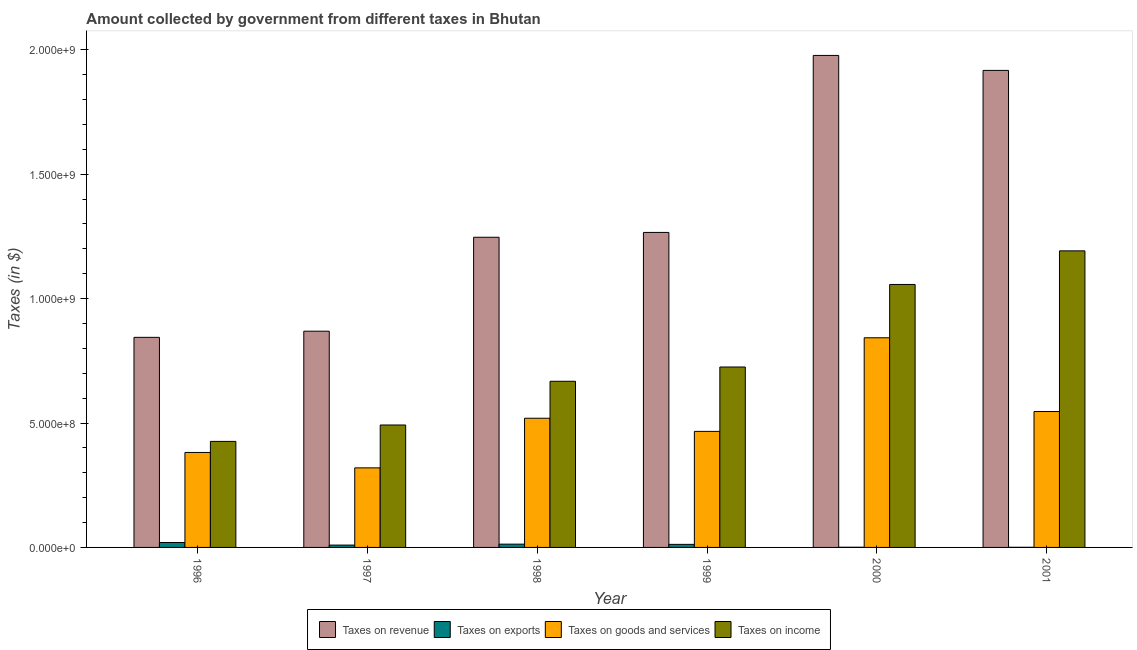How many different coloured bars are there?
Offer a very short reply. 4. How many groups of bars are there?
Your answer should be very brief. 6. Are the number of bars on each tick of the X-axis equal?
Your response must be concise. Yes. What is the amount collected as tax on goods in 1999?
Provide a short and direct response. 4.66e+08. Across all years, what is the maximum amount collected as tax on exports?
Offer a very short reply. 1.98e+07. Across all years, what is the minimum amount collected as tax on exports?
Ensure brevity in your answer.  4.91e+05. In which year was the amount collected as tax on income maximum?
Your answer should be very brief. 2001. In which year was the amount collected as tax on goods minimum?
Offer a very short reply. 1997. What is the total amount collected as tax on goods in the graph?
Provide a succinct answer. 3.08e+09. What is the difference between the amount collected as tax on goods in 1999 and that in 2001?
Your response must be concise. -7.98e+07. What is the difference between the amount collected as tax on revenue in 2001 and the amount collected as tax on goods in 1996?
Offer a very short reply. 1.07e+09. What is the average amount collected as tax on income per year?
Make the answer very short. 7.60e+08. What is the ratio of the amount collected as tax on income in 1996 to that in 1999?
Keep it short and to the point. 0.59. Is the amount collected as tax on goods in 1998 less than that in 1999?
Keep it short and to the point. No. What is the difference between the highest and the second highest amount collected as tax on revenue?
Give a very brief answer. 6.02e+07. What is the difference between the highest and the lowest amount collected as tax on revenue?
Offer a very short reply. 1.13e+09. In how many years, is the amount collected as tax on exports greater than the average amount collected as tax on exports taken over all years?
Keep it short and to the point. 4. Is the sum of the amount collected as tax on income in 1998 and 2001 greater than the maximum amount collected as tax on goods across all years?
Make the answer very short. Yes. Is it the case that in every year, the sum of the amount collected as tax on revenue and amount collected as tax on income is greater than the sum of amount collected as tax on exports and amount collected as tax on goods?
Your answer should be compact. No. What does the 4th bar from the left in 1999 represents?
Give a very brief answer. Taxes on income. What does the 1st bar from the right in 1996 represents?
Give a very brief answer. Taxes on income. Is it the case that in every year, the sum of the amount collected as tax on revenue and amount collected as tax on exports is greater than the amount collected as tax on goods?
Ensure brevity in your answer.  Yes. How many years are there in the graph?
Offer a terse response. 6. What is the difference between two consecutive major ticks on the Y-axis?
Provide a succinct answer. 5.00e+08. Does the graph contain any zero values?
Your answer should be very brief. No. How many legend labels are there?
Provide a short and direct response. 4. How are the legend labels stacked?
Offer a terse response. Horizontal. What is the title of the graph?
Offer a very short reply. Amount collected by government from different taxes in Bhutan. What is the label or title of the X-axis?
Make the answer very short. Year. What is the label or title of the Y-axis?
Give a very brief answer. Taxes (in $). What is the Taxes (in $) in Taxes on revenue in 1996?
Ensure brevity in your answer.  8.44e+08. What is the Taxes (in $) in Taxes on exports in 1996?
Your answer should be very brief. 1.98e+07. What is the Taxes (in $) in Taxes on goods and services in 1996?
Provide a short and direct response. 3.82e+08. What is the Taxes (in $) in Taxes on income in 1996?
Your answer should be very brief. 4.26e+08. What is the Taxes (in $) of Taxes on revenue in 1997?
Offer a terse response. 8.69e+08. What is the Taxes (in $) of Taxes on exports in 1997?
Provide a short and direct response. 9.40e+06. What is the Taxes (in $) in Taxes on goods and services in 1997?
Keep it short and to the point. 3.20e+08. What is the Taxes (in $) of Taxes on income in 1997?
Provide a succinct answer. 4.92e+08. What is the Taxes (in $) in Taxes on revenue in 1998?
Provide a succinct answer. 1.25e+09. What is the Taxes (in $) of Taxes on exports in 1998?
Your answer should be very brief. 1.32e+07. What is the Taxes (in $) in Taxes on goods and services in 1998?
Your answer should be compact. 5.19e+08. What is the Taxes (in $) of Taxes on income in 1998?
Give a very brief answer. 6.68e+08. What is the Taxes (in $) in Taxes on revenue in 1999?
Keep it short and to the point. 1.27e+09. What is the Taxes (in $) in Taxes on exports in 1999?
Give a very brief answer. 1.23e+07. What is the Taxes (in $) in Taxes on goods and services in 1999?
Offer a terse response. 4.66e+08. What is the Taxes (in $) of Taxes on income in 1999?
Your answer should be very brief. 7.25e+08. What is the Taxes (in $) in Taxes on revenue in 2000?
Your response must be concise. 1.98e+09. What is the Taxes (in $) of Taxes on exports in 2000?
Keep it short and to the point. 7.63e+05. What is the Taxes (in $) of Taxes on goods and services in 2000?
Your answer should be compact. 8.42e+08. What is the Taxes (in $) in Taxes on income in 2000?
Provide a short and direct response. 1.06e+09. What is the Taxes (in $) of Taxes on revenue in 2001?
Provide a succinct answer. 1.92e+09. What is the Taxes (in $) in Taxes on exports in 2001?
Offer a very short reply. 4.91e+05. What is the Taxes (in $) of Taxes on goods and services in 2001?
Keep it short and to the point. 5.46e+08. What is the Taxes (in $) in Taxes on income in 2001?
Offer a very short reply. 1.19e+09. Across all years, what is the maximum Taxes (in $) of Taxes on revenue?
Keep it short and to the point. 1.98e+09. Across all years, what is the maximum Taxes (in $) of Taxes on exports?
Make the answer very short. 1.98e+07. Across all years, what is the maximum Taxes (in $) of Taxes on goods and services?
Ensure brevity in your answer.  8.42e+08. Across all years, what is the maximum Taxes (in $) of Taxes on income?
Provide a short and direct response. 1.19e+09. Across all years, what is the minimum Taxes (in $) in Taxes on revenue?
Provide a short and direct response. 8.44e+08. Across all years, what is the minimum Taxes (in $) in Taxes on exports?
Keep it short and to the point. 4.91e+05. Across all years, what is the minimum Taxes (in $) of Taxes on goods and services?
Offer a very short reply. 3.20e+08. Across all years, what is the minimum Taxes (in $) of Taxes on income?
Give a very brief answer. 4.26e+08. What is the total Taxes (in $) of Taxes on revenue in the graph?
Provide a short and direct response. 8.12e+09. What is the total Taxes (in $) in Taxes on exports in the graph?
Provide a succinct answer. 5.59e+07. What is the total Taxes (in $) in Taxes on goods and services in the graph?
Your response must be concise. 3.08e+09. What is the total Taxes (in $) of Taxes on income in the graph?
Provide a short and direct response. 4.56e+09. What is the difference between the Taxes (in $) in Taxes on revenue in 1996 and that in 1997?
Make the answer very short. -2.47e+07. What is the difference between the Taxes (in $) of Taxes on exports in 1996 and that in 1997?
Provide a succinct answer. 1.04e+07. What is the difference between the Taxes (in $) of Taxes on goods and services in 1996 and that in 1997?
Your response must be concise. 6.19e+07. What is the difference between the Taxes (in $) in Taxes on income in 1996 and that in 1997?
Provide a short and direct response. -6.59e+07. What is the difference between the Taxes (in $) in Taxes on revenue in 1996 and that in 1998?
Ensure brevity in your answer.  -4.02e+08. What is the difference between the Taxes (in $) of Taxes on exports in 1996 and that in 1998?
Your answer should be very brief. 6.60e+06. What is the difference between the Taxes (in $) in Taxes on goods and services in 1996 and that in 1998?
Ensure brevity in your answer.  -1.38e+08. What is the difference between the Taxes (in $) in Taxes on income in 1996 and that in 1998?
Offer a very short reply. -2.42e+08. What is the difference between the Taxes (in $) of Taxes on revenue in 1996 and that in 1999?
Give a very brief answer. -4.22e+08. What is the difference between the Taxes (in $) in Taxes on exports in 1996 and that in 1999?
Make the answer very short. 7.51e+06. What is the difference between the Taxes (in $) of Taxes on goods and services in 1996 and that in 1999?
Make the answer very short. -8.47e+07. What is the difference between the Taxes (in $) of Taxes on income in 1996 and that in 1999?
Your response must be concise. -2.99e+08. What is the difference between the Taxes (in $) in Taxes on revenue in 1996 and that in 2000?
Make the answer very short. -1.13e+09. What is the difference between the Taxes (in $) of Taxes on exports in 1996 and that in 2000?
Provide a short and direct response. 1.90e+07. What is the difference between the Taxes (in $) of Taxes on goods and services in 1996 and that in 2000?
Provide a short and direct response. -4.61e+08. What is the difference between the Taxes (in $) of Taxes on income in 1996 and that in 2000?
Provide a succinct answer. -6.31e+08. What is the difference between the Taxes (in $) of Taxes on revenue in 1996 and that in 2001?
Your response must be concise. -1.07e+09. What is the difference between the Taxes (in $) of Taxes on exports in 1996 and that in 2001?
Offer a very short reply. 1.93e+07. What is the difference between the Taxes (in $) of Taxes on goods and services in 1996 and that in 2001?
Ensure brevity in your answer.  -1.64e+08. What is the difference between the Taxes (in $) in Taxes on income in 1996 and that in 2001?
Offer a terse response. -7.66e+08. What is the difference between the Taxes (in $) of Taxes on revenue in 1997 and that in 1998?
Give a very brief answer. -3.77e+08. What is the difference between the Taxes (in $) in Taxes on exports in 1997 and that in 1998?
Your response must be concise. -3.80e+06. What is the difference between the Taxes (in $) of Taxes on goods and services in 1997 and that in 1998?
Your answer should be very brief. -1.99e+08. What is the difference between the Taxes (in $) of Taxes on income in 1997 and that in 1998?
Make the answer very short. -1.76e+08. What is the difference between the Taxes (in $) of Taxes on revenue in 1997 and that in 1999?
Provide a short and direct response. -3.97e+08. What is the difference between the Taxes (in $) of Taxes on exports in 1997 and that in 1999?
Your response must be concise. -2.89e+06. What is the difference between the Taxes (in $) of Taxes on goods and services in 1997 and that in 1999?
Your response must be concise. -1.47e+08. What is the difference between the Taxes (in $) of Taxes on income in 1997 and that in 1999?
Ensure brevity in your answer.  -2.33e+08. What is the difference between the Taxes (in $) in Taxes on revenue in 1997 and that in 2000?
Offer a terse response. -1.11e+09. What is the difference between the Taxes (in $) of Taxes on exports in 1997 and that in 2000?
Ensure brevity in your answer.  8.64e+06. What is the difference between the Taxes (in $) of Taxes on goods and services in 1997 and that in 2000?
Make the answer very short. -5.23e+08. What is the difference between the Taxes (in $) of Taxes on income in 1997 and that in 2000?
Provide a short and direct response. -5.65e+08. What is the difference between the Taxes (in $) in Taxes on revenue in 1997 and that in 2001?
Ensure brevity in your answer.  -1.05e+09. What is the difference between the Taxes (in $) of Taxes on exports in 1997 and that in 2001?
Provide a short and direct response. 8.91e+06. What is the difference between the Taxes (in $) in Taxes on goods and services in 1997 and that in 2001?
Keep it short and to the point. -2.26e+08. What is the difference between the Taxes (in $) in Taxes on income in 1997 and that in 2001?
Provide a short and direct response. -7.00e+08. What is the difference between the Taxes (in $) in Taxes on revenue in 1998 and that in 1999?
Offer a terse response. -1.94e+07. What is the difference between the Taxes (in $) of Taxes on exports in 1998 and that in 1999?
Give a very brief answer. 9.06e+05. What is the difference between the Taxes (in $) in Taxes on goods and services in 1998 and that in 1999?
Provide a succinct answer. 5.28e+07. What is the difference between the Taxes (in $) of Taxes on income in 1998 and that in 1999?
Provide a succinct answer. -5.73e+07. What is the difference between the Taxes (in $) of Taxes on revenue in 1998 and that in 2000?
Your answer should be very brief. -7.31e+08. What is the difference between the Taxes (in $) in Taxes on exports in 1998 and that in 2000?
Make the answer very short. 1.24e+07. What is the difference between the Taxes (in $) of Taxes on goods and services in 1998 and that in 2000?
Make the answer very short. -3.23e+08. What is the difference between the Taxes (in $) of Taxes on income in 1998 and that in 2000?
Make the answer very short. -3.89e+08. What is the difference between the Taxes (in $) in Taxes on revenue in 1998 and that in 2001?
Your response must be concise. -6.71e+08. What is the difference between the Taxes (in $) of Taxes on exports in 1998 and that in 2001?
Make the answer very short. 1.27e+07. What is the difference between the Taxes (in $) of Taxes on goods and services in 1998 and that in 2001?
Offer a very short reply. -2.70e+07. What is the difference between the Taxes (in $) in Taxes on income in 1998 and that in 2001?
Make the answer very short. -5.24e+08. What is the difference between the Taxes (in $) in Taxes on revenue in 1999 and that in 2000?
Give a very brief answer. -7.11e+08. What is the difference between the Taxes (in $) of Taxes on exports in 1999 and that in 2000?
Ensure brevity in your answer.  1.15e+07. What is the difference between the Taxes (in $) of Taxes on goods and services in 1999 and that in 2000?
Keep it short and to the point. -3.76e+08. What is the difference between the Taxes (in $) in Taxes on income in 1999 and that in 2000?
Your response must be concise. -3.32e+08. What is the difference between the Taxes (in $) in Taxes on revenue in 1999 and that in 2001?
Ensure brevity in your answer.  -6.51e+08. What is the difference between the Taxes (in $) of Taxes on exports in 1999 and that in 2001?
Make the answer very short. 1.18e+07. What is the difference between the Taxes (in $) of Taxes on goods and services in 1999 and that in 2001?
Your response must be concise. -7.98e+07. What is the difference between the Taxes (in $) in Taxes on income in 1999 and that in 2001?
Provide a short and direct response. -4.67e+08. What is the difference between the Taxes (in $) of Taxes on revenue in 2000 and that in 2001?
Your answer should be very brief. 6.02e+07. What is the difference between the Taxes (in $) of Taxes on exports in 2000 and that in 2001?
Provide a short and direct response. 2.72e+05. What is the difference between the Taxes (in $) of Taxes on goods and services in 2000 and that in 2001?
Offer a very short reply. 2.96e+08. What is the difference between the Taxes (in $) of Taxes on income in 2000 and that in 2001?
Keep it short and to the point. -1.35e+08. What is the difference between the Taxes (in $) of Taxes on revenue in 1996 and the Taxes (in $) of Taxes on exports in 1997?
Offer a terse response. 8.35e+08. What is the difference between the Taxes (in $) in Taxes on revenue in 1996 and the Taxes (in $) in Taxes on goods and services in 1997?
Provide a succinct answer. 5.24e+08. What is the difference between the Taxes (in $) in Taxes on revenue in 1996 and the Taxes (in $) in Taxes on income in 1997?
Make the answer very short. 3.52e+08. What is the difference between the Taxes (in $) in Taxes on exports in 1996 and the Taxes (in $) in Taxes on goods and services in 1997?
Make the answer very short. -3.00e+08. What is the difference between the Taxes (in $) of Taxes on exports in 1996 and the Taxes (in $) of Taxes on income in 1997?
Your response must be concise. -4.72e+08. What is the difference between the Taxes (in $) of Taxes on goods and services in 1996 and the Taxes (in $) of Taxes on income in 1997?
Keep it short and to the point. -1.10e+08. What is the difference between the Taxes (in $) of Taxes on revenue in 1996 and the Taxes (in $) of Taxes on exports in 1998?
Ensure brevity in your answer.  8.31e+08. What is the difference between the Taxes (in $) of Taxes on revenue in 1996 and the Taxes (in $) of Taxes on goods and services in 1998?
Keep it short and to the point. 3.25e+08. What is the difference between the Taxes (in $) in Taxes on revenue in 1996 and the Taxes (in $) in Taxes on income in 1998?
Offer a very short reply. 1.77e+08. What is the difference between the Taxes (in $) of Taxes on exports in 1996 and the Taxes (in $) of Taxes on goods and services in 1998?
Give a very brief answer. -4.99e+08. What is the difference between the Taxes (in $) in Taxes on exports in 1996 and the Taxes (in $) in Taxes on income in 1998?
Keep it short and to the point. -6.48e+08. What is the difference between the Taxes (in $) in Taxes on goods and services in 1996 and the Taxes (in $) in Taxes on income in 1998?
Make the answer very short. -2.86e+08. What is the difference between the Taxes (in $) of Taxes on revenue in 1996 and the Taxes (in $) of Taxes on exports in 1999?
Ensure brevity in your answer.  8.32e+08. What is the difference between the Taxes (in $) of Taxes on revenue in 1996 and the Taxes (in $) of Taxes on goods and services in 1999?
Ensure brevity in your answer.  3.78e+08. What is the difference between the Taxes (in $) in Taxes on revenue in 1996 and the Taxes (in $) in Taxes on income in 1999?
Make the answer very short. 1.19e+08. What is the difference between the Taxes (in $) of Taxes on exports in 1996 and the Taxes (in $) of Taxes on goods and services in 1999?
Your answer should be very brief. -4.46e+08. What is the difference between the Taxes (in $) of Taxes on exports in 1996 and the Taxes (in $) of Taxes on income in 1999?
Provide a succinct answer. -7.05e+08. What is the difference between the Taxes (in $) in Taxes on goods and services in 1996 and the Taxes (in $) in Taxes on income in 1999?
Your answer should be compact. -3.43e+08. What is the difference between the Taxes (in $) in Taxes on revenue in 1996 and the Taxes (in $) in Taxes on exports in 2000?
Your response must be concise. 8.43e+08. What is the difference between the Taxes (in $) of Taxes on revenue in 1996 and the Taxes (in $) of Taxes on goods and services in 2000?
Provide a short and direct response. 1.70e+06. What is the difference between the Taxes (in $) of Taxes on revenue in 1996 and the Taxes (in $) of Taxes on income in 2000?
Provide a succinct answer. -2.12e+08. What is the difference between the Taxes (in $) of Taxes on exports in 1996 and the Taxes (in $) of Taxes on goods and services in 2000?
Give a very brief answer. -8.23e+08. What is the difference between the Taxes (in $) of Taxes on exports in 1996 and the Taxes (in $) of Taxes on income in 2000?
Make the answer very short. -1.04e+09. What is the difference between the Taxes (in $) in Taxes on goods and services in 1996 and the Taxes (in $) in Taxes on income in 2000?
Give a very brief answer. -6.75e+08. What is the difference between the Taxes (in $) of Taxes on revenue in 1996 and the Taxes (in $) of Taxes on exports in 2001?
Keep it short and to the point. 8.44e+08. What is the difference between the Taxes (in $) of Taxes on revenue in 1996 and the Taxes (in $) of Taxes on goods and services in 2001?
Provide a short and direct response. 2.98e+08. What is the difference between the Taxes (in $) of Taxes on revenue in 1996 and the Taxes (in $) of Taxes on income in 2001?
Provide a short and direct response. -3.48e+08. What is the difference between the Taxes (in $) of Taxes on exports in 1996 and the Taxes (in $) of Taxes on goods and services in 2001?
Your answer should be compact. -5.26e+08. What is the difference between the Taxes (in $) in Taxes on exports in 1996 and the Taxes (in $) in Taxes on income in 2001?
Provide a short and direct response. -1.17e+09. What is the difference between the Taxes (in $) of Taxes on goods and services in 1996 and the Taxes (in $) of Taxes on income in 2001?
Your answer should be compact. -8.10e+08. What is the difference between the Taxes (in $) of Taxes on revenue in 1997 and the Taxes (in $) of Taxes on exports in 1998?
Your answer should be very brief. 8.56e+08. What is the difference between the Taxes (in $) in Taxes on revenue in 1997 and the Taxes (in $) in Taxes on goods and services in 1998?
Offer a very short reply. 3.50e+08. What is the difference between the Taxes (in $) in Taxes on revenue in 1997 and the Taxes (in $) in Taxes on income in 1998?
Give a very brief answer. 2.01e+08. What is the difference between the Taxes (in $) in Taxes on exports in 1997 and the Taxes (in $) in Taxes on goods and services in 1998?
Offer a very short reply. -5.10e+08. What is the difference between the Taxes (in $) in Taxes on exports in 1997 and the Taxes (in $) in Taxes on income in 1998?
Give a very brief answer. -6.58e+08. What is the difference between the Taxes (in $) of Taxes on goods and services in 1997 and the Taxes (in $) of Taxes on income in 1998?
Your answer should be very brief. -3.48e+08. What is the difference between the Taxes (in $) in Taxes on revenue in 1997 and the Taxes (in $) in Taxes on exports in 1999?
Keep it short and to the point. 8.57e+08. What is the difference between the Taxes (in $) of Taxes on revenue in 1997 and the Taxes (in $) of Taxes on goods and services in 1999?
Your response must be concise. 4.03e+08. What is the difference between the Taxes (in $) in Taxes on revenue in 1997 and the Taxes (in $) in Taxes on income in 1999?
Give a very brief answer. 1.44e+08. What is the difference between the Taxes (in $) in Taxes on exports in 1997 and the Taxes (in $) in Taxes on goods and services in 1999?
Offer a very short reply. -4.57e+08. What is the difference between the Taxes (in $) of Taxes on exports in 1997 and the Taxes (in $) of Taxes on income in 1999?
Offer a terse response. -7.16e+08. What is the difference between the Taxes (in $) in Taxes on goods and services in 1997 and the Taxes (in $) in Taxes on income in 1999?
Offer a terse response. -4.05e+08. What is the difference between the Taxes (in $) in Taxes on revenue in 1997 and the Taxes (in $) in Taxes on exports in 2000?
Your answer should be compact. 8.68e+08. What is the difference between the Taxes (in $) of Taxes on revenue in 1997 and the Taxes (in $) of Taxes on goods and services in 2000?
Your answer should be very brief. 2.64e+07. What is the difference between the Taxes (in $) in Taxes on revenue in 1997 and the Taxes (in $) in Taxes on income in 2000?
Your answer should be compact. -1.88e+08. What is the difference between the Taxes (in $) of Taxes on exports in 1997 and the Taxes (in $) of Taxes on goods and services in 2000?
Your answer should be very brief. -8.33e+08. What is the difference between the Taxes (in $) of Taxes on exports in 1997 and the Taxes (in $) of Taxes on income in 2000?
Give a very brief answer. -1.05e+09. What is the difference between the Taxes (in $) of Taxes on goods and services in 1997 and the Taxes (in $) of Taxes on income in 2000?
Provide a succinct answer. -7.37e+08. What is the difference between the Taxes (in $) in Taxes on revenue in 1997 and the Taxes (in $) in Taxes on exports in 2001?
Keep it short and to the point. 8.68e+08. What is the difference between the Taxes (in $) of Taxes on revenue in 1997 and the Taxes (in $) of Taxes on goods and services in 2001?
Give a very brief answer. 3.23e+08. What is the difference between the Taxes (in $) in Taxes on revenue in 1997 and the Taxes (in $) in Taxes on income in 2001?
Keep it short and to the point. -3.23e+08. What is the difference between the Taxes (in $) in Taxes on exports in 1997 and the Taxes (in $) in Taxes on goods and services in 2001?
Your response must be concise. -5.37e+08. What is the difference between the Taxes (in $) of Taxes on exports in 1997 and the Taxes (in $) of Taxes on income in 2001?
Offer a very short reply. -1.18e+09. What is the difference between the Taxes (in $) of Taxes on goods and services in 1997 and the Taxes (in $) of Taxes on income in 2001?
Ensure brevity in your answer.  -8.72e+08. What is the difference between the Taxes (in $) of Taxes on revenue in 1998 and the Taxes (in $) of Taxes on exports in 1999?
Keep it short and to the point. 1.23e+09. What is the difference between the Taxes (in $) in Taxes on revenue in 1998 and the Taxes (in $) in Taxes on goods and services in 1999?
Provide a short and direct response. 7.80e+08. What is the difference between the Taxes (in $) in Taxes on revenue in 1998 and the Taxes (in $) in Taxes on income in 1999?
Provide a succinct answer. 5.21e+08. What is the difference between the Taxes (in $) of Taxes on exports in 1998 and the Taxes (in $) of Taxes on goods and services in 1999?
Keep it short and to the point. -4.53e+08. What is the difference between the Taxes (in $) of Taxes on exports in 1998 and the Taxes (in $) of Taxes on income in 1999?
Offer a terse response. -7.12e+08. What is the difference between the Taxes (in $) of Taxes on goods and services in 1998 and the Taxes (in $) of Taxes on income in 1999?
Ensure brevity in your answer.  -2.06e+08. What is the difference between the Taxes (in $) of Taxes on revenue in 1998 and the Taxes (in $) of Taxes on exports in 2000?
Give a very brief answer. 1.25e+09. What is the difference between the Taxes (in $) in Taxes on revenue in 1998 and the Taxes (in $) in Taxes on goods and services in 2000?
Your answer should be very brief. 4.04e+08. What is the difference between the Taxes (in $) of Taxes on revenue in 1998 and the Taxes (in $) of Taxes on income in 2000?
Your response must be concise. 1.90e+08. What is the difference between the Taxes (in $) of Taxes on exports in 1998 and the Taxes (in $) of Taxes on goods and services in 2000?
Make the answer very short. -8.29e+08. What is the difference between the Taxes (in $) in Taxes on exports in 1998 and the Taxes (in $) in Taxes on income in 2000?
Your response must be concise. -1.04e+09. What is the difference between the Taxes (in $) in Taxes on goods and services in 1998 and the Taxes (in $) in Taxes on income in 2000?
Your response must be concise. -5.38e+08. What is the difference between the Taxes (in $) of Taxes on revenue in 1998 and the Taxes (in $) of Taxes on exports in 2001?
Give a very brief answer. 1.25e+09. What is the difference between the Taxes (in $) in Taxes on revenue in 1998 and the Taxes (in $) in Taxes on goods and services in 2001?
Ensure brevity in your answer.  7.00e+08. What is the difference between the Taxes (in $) of Taxes on revenue in 1998 and the Taxes (in $) of Taxes on income in 2001?
Ensure brevity in your answer.  5.46e+07. What is the difference between the Taxes (in $) of Taxes on exports in 1998 and the Taxes (in $) of Taxes on goods and services in 2001?
Keep it short and to the point. -5.33e+08. What is the difference between the Taxes (in $) in Taxes on exports in 1998 and the Taxes (in $) in Taxes on income in 2001?
Provide a short and direct response. -1.18e+09. What is the difference between the Taxes (in $) in Taxes on goods and services in 1998 and the Taxes (in $) in Taxes on income in 2001?
Provide a short and direct response. -6.73e+08. What is the difference between the Taxes (in $) in Taxes on revenue in 1999 and the Taxes (in $) in Taxes on exports in 2000?
Offer a very short reply. 1.27e+09. What is the difference between the Taxes (in $) in Taxes on revenue in 1999 and the Taxes (in $) in Taxes on goods and services in 2000?
Make the answer very short. 4.23e+08. What is the difference between the Taxes (in $) of Taxes on revenue in 1999 and the Taxes (in $) of Taxes on income in 2000?
Make the answer very short. 2.09e+08. What is the difference between the Taxes (in $) in Taxes on exports in 1999 and the Taxes (in $) in Taxes on goods and services in 2000?
Make the answer very short. -8.30e+08. What is the difference between the Taxes (in $) in Taxes on exports in 1999 and the Taxes (in $) in Taxes on income in 2000?
Provide a succinct answer. -1.04e+09. What is the difference between the Taxes (in $) in Taxes on goods and services in 1999 and the Taxes (in $) in Taxes on income in 2000?
Offer a terse response. -5.90e+08. What is the difference between the Taxes (in $) of Taxes on revenue in 1999 and the Taxes (in $) of Taxes on exports in 2001?
Your answer should be very brief. 1.27e+09. What is the difference between the Taxes (in $) of Taxes on revenue in 1999 and the Taxes (in $) of Taxes on goods and services in 2001?
Offer a terse response. 7.20e+08. What is the difference between the Taxes (in $) of Taxes on revenue in 1999 and the Taxes (in $) of Taxes on income in 2001?
Your answer should be very brief. 7.40e+07. What is the difference between the Taxes (in $) of Taxes on exports in 1999 and the Taxes (in $) of Taxes on goods and services in 2001?
Keep it short and to the point. -5.34e+08. What is the difference between the Taxes (in $) in Taxes on exports in 1999 and the Taxes (in $) in Taxes on income in 2001?
Your response must be concise. -1.18e+09. What is the difference between the Taxes (in $) in Taxes on goods and services in 1999 and the Taxes (in $) in Taxes on income in 2001?
Keep it short and to the point. -7.25e+08. What is the difference between the Taxes (in $) of Taxes on revenue in 2000 and the Taxes (in $) of Taxes on exports in 2001?
Offer a terse response. 1.98e+09. What is the difference between the Taxes (in $) of Taxes on revenue in 2000 and the Taxes (in $) of Taxes on goods and services in 2001?
Your response must be concise. 1.43e+09. What is the difference between the Taxes (in $) in Taxes on revenue in 2000 and the Taxes (in $) in Taxes on income in 2001?
Give a very brief answer. 7.85e+08. What is the difference between the Taxes (in $) of Taxes on exports in 2000 and the Taxes (in $) of Taxes on goods and services in 2001?
Offer a terse response. -5.45e+08. What is the difference between the Taxes (in $) of Taxes on exports in 2000 and the Taxes (in $) of Taxes on income in 2001?
Offer a terse response. -1.19e+09. What is the difference between the Taxes (in $) in Taxes on goods and services in 2000 and the Taxes (in $) in Taxes on income in 2001?
Provide a succinct answer. -3.49e+08. What is the average Taxes (in $) in Taxes on revenue per year?
Provide a succinct answer. 1.35e+09. What is the average Taxes (in $) of Taxes on exports per year?
Provide a succinct answer. 9.32e+06. What is the average Taxes (in $) in Taxes on goods and services per year?
Your answer should be very brief. 5.13e+08. What is the average Taxes (in $) of Taxes on income per year?
Offer a very short reply. 7.60e+08. In the year 1996, what is the difference between the Taxes (in $) of Taxes on revenue and Taxes (in $) of Taxes on exports?
Your response must be concise. 8.24e+08. In the year 1996, what is the difference between the Taxes (in $) of Taxes on revenue and Taxes (in $) of Taxes on goods and services?
Keep it short and to the point. 4.63e+08. In the year 1996, what is the difference between the Taxes (in $) in Taxes on revenue and Taxes (in $) in Taxes on income?
Your answer should be very brief. 4.18e+08. In the year 1996, what is the difference between the Taxes (in $) of Taxes on exports and Taxes (in $) of Taxes on goods and services?
Keep it short and to the point. -3.62e+08. In the year 1996, what is the difference between the Taxes (in $) in Taxes on exports and Taxes (in $) in Taxes on income?
Offer a terse response. -4.06e+08. In the year 1996, what is the difference between the Taxes (in $) of Taxes on goods and services and Taxes (in $) of Taxes on income?
Offer a terse response. -4.45e+07. In the year 1997, what is the difference between the Taxes (in $) in Taxes on revenue and Taxes (in $) in Taxes on exports?
Offer a terse response. 8.60e+08. In the year 1997, what is the difference between the Taxes (in $) of Taxes on revenue and Taxes (in $) of Taxes on goods and services?
Your answer should be compact. 5.49e+08. In the year 1997, what is the difference between the Taxes (in $) of Taxes on revenue and Taxes (in $) of Taxes on income?
Offer a terse response. 3.77e+08. In the year 1997, what is the difference between the Taxes (in $) of Taxes on exports and Taxes (in $) of Taxes on goods and services?
Your answer should be very brief. -3.10e+08. In the year 1997, what is the difference between the Taxes (in $) in Taxes on exports and Taxes (in $) in Taxes on income?
Keep it short and to the point. -4.83e+08. In the year 1997, what is the difference between the Taxes (in $) of Taxes on goods and services and Taxes (in $) of Taxes on income?
Provide a succinct answer. -1.72e+08. In the year 1998, what is the difference between the Taxes (in $) of Taxes on revenue and Taxes (in $) of Taxes on exports?
Provide a short and direct response. 1.23e+09. In the year 1998, what is the difference between the Taxes (in $) in Taxes on revenue and Taxes (in $) in Taxes on goods and services?
Offer a terse response. 7.27e+08. In the year 1998, what is the difference between the Taxes (in $) of Taxes on revenue and Taxes (in $) of Taxes on income?
Make the answer very short. 5.79e+08. In the year 1998, what is the difference between the Taxes (in $) in Taxes on exports and Taxes (in $) in Taxes on goods and services?
Offer a very short reply. -5.06e+08. In the year 1998, what is the difference between the Taxes (in $) in Taxes on exports and Taxes (in $) in Taxes on income?
Provide a short and direct response. -6.54e+08. In the year 1998, what is the difference between the Taxes (in $) in Taxes on goods and services and Taxes (in $) in Taxes on income?
Offer a terse response. -1.49e+08. In the year 1999, what is the difference between the Taxes (in $) of Taxes on revenue and Taxes (in $) of Taxes on exports?
Your answer should be compact. 1.25e+09. In the year 1999, what is the difference between the Taxes (in $) of Taxes on revenue and Taxes (in $) of Taxes on goods and services?
Provide a succinct answer. 8.00e+08. In the year 1999, what is the difference between the Taxes (in $) in Taxes on revenue and Taxes (in $) in Taxes on income?
Provide a short and direct response. 5.41e+08. In the year 1999, what is the difference between the Taxes (in $) in Taxes on exports and Taxes (in $) in Taxes on goods and services?
Give a very brief answer. -4.54e+08. In the year 1999, what is the difference between the Taxes (in $) in Taxes on exports and Taxes (in $) in Taxes on income?
Your answer should be compact. -7.13e+08. In the year 1999, what is the difference between the Taxes (in $) of Taxes on goods and services and Taxes (in $) of Taxes on income?
Your answer should be very brief. -2.59e+08. In the year 2000, what is the difference between the Taxes (in $) in Taxes on revenue and Taxes (in $) in Taxes on exports?
Your answer should be compact. 1.98e+09. In the year 2000, what is the difference between the Taxes (in $) of Taxes on revenue and Taxes (in $) of Taxes on goods and services?
Your answer should be very brief. 1.13e+09. In the year 2000, what is the difference between the Taxes (in $) in Taxes on revenue and Taxes (in $) in Taxes on income?
Give a very brief answer. 9.20e+08. In the year 2000, what is the difference between the Taxes (in $) of Taxes on exports and Taxes (in $) of Taxes on goods and services?
Provide a short and direct response. -8.42e+08. In the year 2000, what is the difference between the Taxes (in $) of Taxes on exports and Taxes (in $) of Taxes on income?
Your answer should be very brief. -1.06e+09. In the year 2000, what is the difference between the Taxes (in $) in Taxes on goods and services and Taxes (in $) in Taxes on income?
Provide a succinct answer. -2.14e+08. In the year 2001, what is the difference between the Taxes (in $) in Taxes on revenue and Taxes (in $) in Taxes on exports?
Provide a succinct answer. 1.92e+09. In the year 2001, what is the difference between the Taxes (in $) of Taxes on revenue and Taxes (in $) of Taxes on goods and services?
Keep it short and to the point. 1.37e+09. In the year 2001, what is the difference between the Taxes (in $) of Taxes on revenue and Taxes (in $) of Taxes on income?
Keep it short and to the point. 7.25e+08. In the year 2001, what is the difference between the Taxes (in $) in Taxes on exports and Taxes (in $) in Taxes on goods and services?
Your answer should be very brief. -5.46e+08. In the year 2001, what is the difference between the Taxes (in $) of Taxes on exports and Taxes (in $) of Taxes on income?
Provide a succinct answer. -1.19e+09. In the year 2001, what is the difference between the Taxes (in $) in Taxes on goods and services and Taxes (in $) in Taxes on income?
Offer a terse response. -6.46e+08. What is the ratio of the Taxes (in $) in Taxes on revenue in 1996 to that in 1997?
Your response must be concise. 0.97. What is the ratio of the Taxes (in $) in Taxes on exports in 1996 to that in 1997?
Provide a short and direct response. 2.11. What is the ratio of the Taxes (in $) of Taxes on goods and services in 1996 to that in 1997?
Offer a very short reply. 1.19. What is the ratio of the Taxes (in $) of Taxes on income in 1996 to that in 1997?
Your answer should be compact. 0.87. What is the ratio of the Taxes (in $) of Taxes on revenue in 1996 to that in 1998?
Ensure brevity in your answer.  0.68. What is the ratio of the Taxes (in $) in Taxes on exports in 1996 to that in 1998?
Provide a succinct answer. 1.5. What is the ratio of the Taxes (in $) in Taxes on goods and services in 1996 to that in 1998?
Offer a terse response. 0.74. What is the ratio of the Taxes (in $) of Taxes on income in 1996 to that in 1998?
Keep it short and to the point. 0.64. What is the ratio of the Taxes (in $) of Taxes on revenue in 1996 to that in 1999?
Ensure brevity in your answer.  0.67. What is the ratio of the Taxes (in $) of Taxes on exports in 1996 to that in 1999?
Provide a short and direct response. 1.61. What is the ratio of the Taxes (in $) of Taxes on goods and services in 1996 to that in 1999?
Ensure brevity in your answer.  0.82. What is the ratio of the Taxes (in $) of Taxes on income in 1996 to that in 1999?
Keep it short and to the point. 0.59. What is the ratio of the Taxes (in $) in Taxes on revenue in 1996 to that in 2000?
Your answer should be compact. 0.43. What is the ratio of the Taxes (in $) of Taxes on exports in 1996 to that in 2000?
Ensure brevity in your answer.  25.95. What is the ratio of the Taxes (in $) of Taxes on goods and services in 1996 to that in 2000?
Keep it short and to the point. 0.45. What is the ratio of the Taxes (in $) in Taxes on income in 1996 to that in 2000?
Your answer should be compact. 0.4. What is the ratio of the Taxes (in $) in Taxes on revenue in 1996 to that in 2001?
Offer a very short reply. 0.44. What is the ratio of the Taxes (in $) in Taxes on exports in 1996 to that in 2001?
Provide a short and direct response. 40.33. What is the ratio of the Taxes (in $) of Taxes on goods and services in 1996 to that in 2001?
Give a very brief answer. 0.7. What is the ratio of the Taxes (in $) of Taxes on income in 1996 to that in 2001?
Give a very brief answer. 0.36. What is the ratio of the Taxes (in $) of Taxes on revenue in 1997 to that in 1998?
Provide a succinct answer. 0.7. What is the ratio of the Taxes (in $) in Taxes on exports in 1997 to that in 1998?
Offer a terse response. 0.71. What is the ratio of the Taxes (in $) of Taxes on goods and services in 1997 to that in 1998?
Keep it short and to the point. 0.62. What is the ratio of the Taxes (in $) of Taxes on income in 1997 to that in 1998?
Give a very brief answer. 0.74. What is the ratio of the Taxes (in $) in Taxes on revenue in 1997 to that in 1999?
Provide a short and direct response. 0.69. What is the ratio of the Taxes (in $) of Taxes on exports in 1997 to that in 1999?
Keep it short and to the point. 0.76. What is the ratio of the Taxes (in $) of Taxes on goods and services in 1997 to that in 1999?
Your response must be concise. 0.69. What is the ratio of the Taxes (in $) of Taxes on income in 1997 to that in 1999?
Give a very brief answer. 0.68. What is the ratio of the Taxes (in $) of Taxes on revenue in 1997 to that in 2000?
Keep it short and to the point. 0.44. What is the ratio of the Taxes (in $) in Taxes on exports in 1997 to that in 2000?
Offer a very short reply. 12.32. What is the ratio of the Taxes (in $) of Taxes on goods and services in 1997 to that in 2000?
Offer a very short reply. 0.38. What is the ratio of the Taxes (in $) of Taxes on income in 1997 to that in 2000?
Keep it short and to the point. 0.47. What is the ratio of the Taxes (in $) of Taxes on revenue in 1997 to that in 2001?
Give a very brief answer. 0.45. What is the ratio of the Taxes (in $) of Taxes on exports in 1997 to that in 2001?
Your answer should be very brief. 19.14. What is the ratio of the Taxes (in $) of Taxes on goods and services in 1997 to that in 2001?
Your response must be concise. 0.59. What is the ratio of the Taxes (in $) of Taxes on income in 1997 to that in 2001?
Offer a very short reply. 0.41. What is the ratio of the Taxes (in $) of Taxes on revenue in 1998 to that in 1999?
Make the answer very short. 0.98. What is the ratio of the Taxes (in $) in Taxes on exports in 1998 to that in 1999?
Your answer should be compact. 1.07. What is the ratio of the Taxes (in $) of Taxes on goods and services in 1998 to that in 1999?
Ensure brevity in your answer.  1.11. What is the ratio of the Taxes (in $) in Taxes on income in 1998 to that in 1999?
Make the answer very short. 0.92. What is the ratio of the Taxes (in $) of Taxes on revenue in 1998 to that in 2000?
Provide a short and direct response. 0.63. What is the ratio of the Taxes (in $) in Taxes on exports in 1998 to that in 2000?
Keep it short and to the point. 17.3. What is the ratio of the Taxes (in $) in Taxes on goods and services in 1998 to that in 2000?
Provide a short and direct response. 0.62. What is the ratio of the Taxes (in $) of Taxes on income in 1998 to that in 2000?
Offer a very short reply. 0.63. What is the ratio of the Taxes (in $) in Taxes on revenue in 1998 to that in 2001?
Make the answer very short. 0.65. What is the ratio of the Taxes (in $) of Taxes on exports in 1998 to that in 2001?
Make the answer very short. 26.88. What is the ratio of the Taxes (in $) of Taxes on goods and services in 1998 to that in 2001?
Provide a short and direct response. 0.95. What is the ratio of the Taxes (in $) in Taxes on income in 1998 to that in 2001?
Your response must be concise. 0.56. What is the ratio of the Taxes (in $) of Taxes on revenue in 1999 to that in 2000?
Ensure brevity in your answer.  0.64. What is the ratio of the Taxes (in $) in Taxes on exports in 1999 to that in 2000?
Keep it short and to the point. 16.11. What is the ratio of the Taxes (in $) in Taxes on goods and services in 1999 to that in 2000?
Ensure brevity in your answer.  0.55. What is the ratio of the Taxes (in $) of Taxes on income in 1999 to that in 2000?
Your answer should be compact. 0.69. What is the ratio of the Taxes (in $) of Taxes on revenue in 1999 to that in 2001?
Keep it short and to the point. 0.66. What is the ratio of the Taxes (in $) in Taxes on exports in 1999 to that in 2001?
Give a very brief answer. 25.04. What is the ratio of the Taxes (in $) in Taxes on goods and services in 1999 to that in 2001?
Your response must be concise. 0.85. What is the ratio of the Taxes (in $) in Taxes on income in 1999 to that in 2001?
Offer a terse response. 0.61. What is the ratio of the Taxes (in $) in Taxes on revenue in 2000 to that in 2001?
Provide a succinct answer. 1.03. What is the ratio of the Taxes (in $) in Taxes on exports in 2000 to that in 2001?
Your response must be concise. 1.55. What is the ratio of the Taxes (in $) of Taxes on goods and services in 2000 to that in 2001?
Your response must be concise. 1.54. What is the ratio of the Taxes (in $) in Taxes on income in 2000 to that in 2001?
Give a very brief answer. 0.89. What is the difference between the highest and the second highest Taxes (in $) in Taxes on revenue?
Provide a succinct answer. 6.02e+07. What is the difference between the highest and the second highest Taxes (in $) in Taxes on exports?
Offer a terse response. 6.60e+06. What is the difference between the highest and the second highest Taxes (in $) of Taxes on goods and services?
Ensure brevity in your answer.  2.96e+08. What is the difference between the highest and the second highest Taxes (in $) of Taxes on income?
Make the answer very short. 1.35e+08. What is the difference between the highest and the lowest Taxes (in $) in Taxes on revenue?
Keep it short and to the point. 1.13e+09. What is the difference between the highest and the lowest Taxes (in $) in Taxes on exports?
Ensure brevity in your answer.  1.93e+07. What is the difference between the highest and the lowest Taxes (in $) in Taxes on goods and services?
Keep it short and to the point. 5.23e+08. What is the difference between the highest and the lowest Taxes (in $) in Taxes on income?
Offer a terse response. 7.66e+08. 